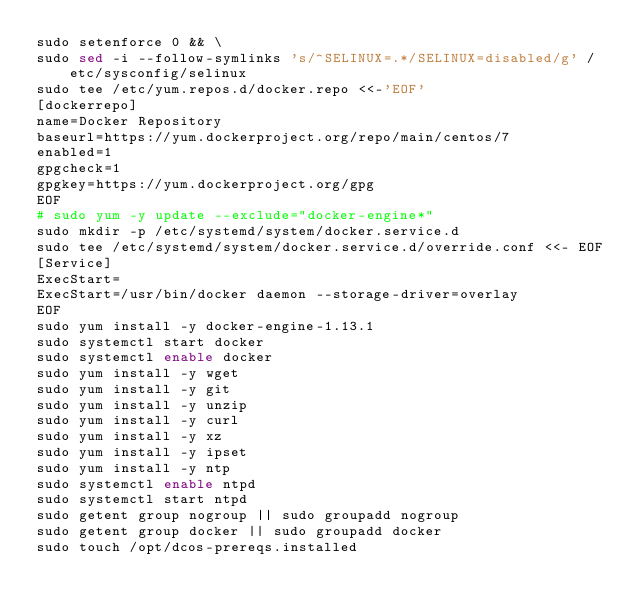<code> <loc_0><loc_0><loc_500><loc_500><_Bash_>sudo setenforce 0 && \
sudo sed -i --follow-symlinks 's/^SELINUX=.*/SELINUX=disabled/g' /etc/sysconfig/selinux
sudo tee /etc/yum.repos.d/docker.repo <<-'EOF'
[dockerrepo]
name=Docker Repository
baseurl=https://yum.dockerproject.org/repo/main/centos/7
enabled=1
gpgcheck=1
gpgkey=https://yum.dockerproject.org/gpg
EOF
# sudo yum -y update --exclude="docker-engine*"
sudo mkdir -p /etc/systemd/system/docker.service.d
sudo tee /etc/systemd/system/docker.service.d/override.conf <<- EOF
[Service]
ExecStart=
ExecStart=/usr/bin/docker daemon --storage-driver=overlay
EOF
sudo yum install -y docker-engine-1.13.1
sudo systemctl start docker
sudo systemctl enable docker
sudo yum install -y wget
sudo yum install -y git
sudo yum install -y unzip
sudo yum install -y curl
sudo yum install -y xz
sudo yum install -y ipset
sudo yum install -y ntp
sudo systemctl enable ntpd
sudo systemctl start ntpd
sudo getent group nogroup || sudo groupadd nogroup
sudo getent group docker || sudo groupadd docker
sudo touch /opt/dcos-prereqs.installed
</code> 